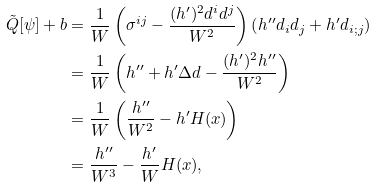Convert formula to latex. <formula><loc_0><loc_0><loc_500><loc_500>\tilde { Q } [ \psi ] + b & = \frac { 1 } { W } \left ( \sigma ^ { i j } - \frac { ( h ^ { \prime } ) ^ { 2 } d ^ { i } d ^ { j } } { W ^ { 2 } } \right ) \left ( h ^ { \prime \prime } d _ { i } d _ { j } + h ^ { \prime } d _ { i ; j } \right ) \\ & = \frac { 1 } { W } \left ( h ^ { \prime \prime } + h ^ { \prime } \Delta d - \frac { ( h ^ { \prime } ) ^ { 2 } h ^ { \prime \prime } } { W ^ { 2 } } \right ) \\ & = \frac { 1 } { W } \left ( \frac { h ^ { \prime \prime } } { W ^ { 2 } } - h ^ { \prime } H ( x ) \right ) \\ & = \frac { h ^ { \prime \prime } } { W ^ { 3 } } - \frac { h ^ { \prime } } { W } H ( x ) ,</formula> 